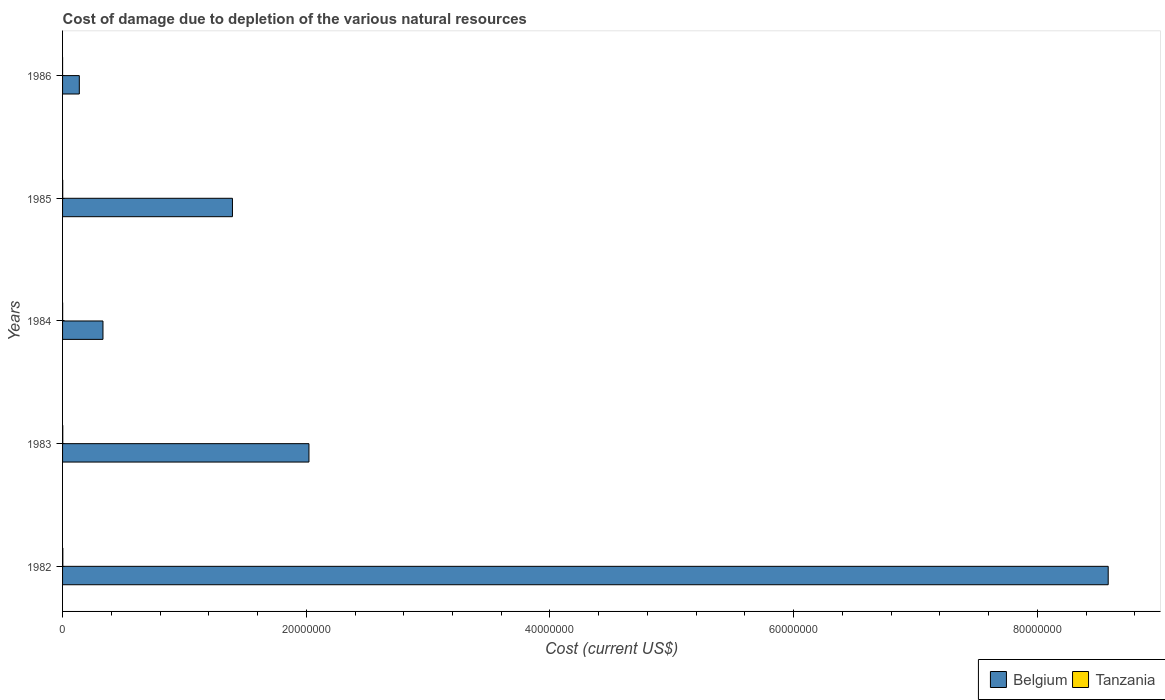How many bars are there on the 1st tick from the bottom?
Your response must be concise. 2. What is the label of the 5th group of bars from the top?
Ensure brevity in your answer.  1982. What is the cost of damage caused due to the depletion of various natural resources in Tanzania in 1986?
Ensure brevity in your answer.  129.44. Across all years, what is the maximum cost of damage caused due to the depletion of various natural resources in Tanzania?
Ensure brevity in your answer.  2.12e+04. Across all years, what is the minimum cost of damage caused due to the depletion of various natural resources in Tanzania?
Keep it short and to the point. 129.44. In which year was the cost of damage caused due to the depletion of various natural resources in Tanzania maximum?
Provide a short and direct response. 1982. What is the total cost of damage caused due to the depletion of various natural resources in Tanzania in the graph?
Your response must be concise. 5.66e+04. What is the difference between the cost of damage caused due to the depletion of various natural resources in Belgium in 1984 and that in 1985?
Offer a very short reply. -1.06e+07. What is the difference between the cost of damage caused due to the depletion of various natural resources in Tanzania in 1985 and the cost of damage caused due to the depletion of various natural resources in Belgium in 1984?
Offer a terse response. -3.30e+06. What is the average cost of damage caused due to the depletion of various natural resources in Belgium per year?
Provide a succinct answer. 2.49e+07. In the year 1984, what is the difference between the cost of damage caused due to the depletion of various natural resources in Tanzania and cost of damage caused due to the depletion of various natural resources in Belgium?
Provide a succinct answer. -3.31e+06. What is the ratio of the cost of damage caused due to the depletion of various natural resources in Belgium in 1983 to that in 1984?
Offer a terse response. 6.1. What is the difference between the highest and the second highest cost of damage caused due to the depletion of various natural resources in Tanzania?
Your answer should be compact. 4899.83. What is the difference between the highest and the lowest cost of damage caused due to the depletion of various natural resources in Belgium?
Keep it short and to the point. 8.44e+07. In how many years, is the cost of damage caused due to the depletion of various natural resources in Tanzania greater than the average cost of damage caused due to the depletion of various natural resources in Tanzania taken over all years?
Offer a very short reply. 3. Is the sum of the cost of damage caused due to the depletion of various natural resources in Tanzania in 1983 and 1985 greater than the maximum cost of damage caused due to the depletion of various natural resources in Belgium across all years?
Your answer should be compact. No. What does the 2nd bar from the bottom in 1985 represents?
Give a very brief answer. Tanzania. How many bars are there?
Offer a terse response. 10. How many years are there in the graph?
Provide a short and direct response. 5. What is the difference between two consecutive major ticks on the X-axis?
Offer a terse response. 2.00e+07. Does the graph contain any zero values?
Offer a very short reply. No. Does the graph contain grids?
Give a very brief answer. No. Where does the legend appear in the graph?
Your response must be concise. Bottom right. How many legend labels are there?
Offer a terse response. 2. How are the legend labels stacked?
Ensure brevity in your answer.  Horizontal. What is the title of the graph?
Your answer should be compact. Cost of damage due to depletion of the various natural resources. What is the label or title of the X-axis?
Your response must be concise. Cost (current US$). What is the Cost (current US$) of Belgium in 1982?
Provide a succinct answer. 8.58e+07. What is the Cost (current US$) in Tanzania in 1982?
Offer a very short reply. 2.12e+04. What is the Cost (current US$) in Belgium in 1983?
Keep it short and to the point. 2.02e+07. What is the Cost (current US$) in Tanzania in 1983?
Provide a succinct answer. 1.63e+04. What is the Cost (current US$) in Belgium in 1984?
Make the answer very short. 3.32e+06. What is the Cost (current US$) in Tanzania in 1984?
Your response must be concise. 6142.58. What is the Cost (current US$) in Belgium in 1985?
Give a very brief answer. 1.39e+07. What is the Cost (current US$) of Tanzania in 1985?
Provide a succinct answer. 1.28e+04. What is the Cost (current US$) in Belgium in 1986?
Provide a succinct answer. 1.37e+06. What is the Cost (current US$) in Tanzania in 1986?
Provide a succinct answer. 129.44. Across all years, what is the maximum Cost (current US$) in Belgium?
Your answer should be very brief. 8.58e+07. Across all years, what is the maximum Cost (current US$) in Tanzania?
Your answer should be very brief. 2.12e+04. Across all years, what is the minimum Cost (current US$) of Belgium?
Your answer should be compact. 1.37e+06. Across all years, what is the minimum Cost (current US$) of Tanzania?
Provide a short and direct response. 129.44. What is the total Cost (current US$) in Belgium in the graph?
Your response must be concise. 1.25e+08. What is the total Cost (current US$) in Tanzania in the graph?
Your answer should be compact. 5.66e+04. What is the difference between the Cost (current US$) in Belgium in 1982 and that in 1983?
Give a very brief answer. 6.56e+07. What is the difference between the Cost (current US$) of Tanzania in 1982 and that in 1983?
Give a very brief answer. 4899.84. What is the difference between the Cost (current US$) in Belgium in 1982 and that in 1984?
Offer a very short reply. 8.25e+07. What is the difference between the Cost (current US$) of Tanzania in 1982 and that in 1984?
Give a very brief answer. 1.51e+04. What is the difference between the Cost (current US$) of Belgium in 1982 and that in 1985?
Make the answer very short. 7.19e+07. What is the difference between the Cost (current US$) in Tanzania in 1982 and that in 1985?
Your answer should be very brief. 8418.63. What is the difference between the Cost (current US$) of Belgium in 1982 and that in 1986?
Give a very brief answer. 8.44e+07. What is the difference between the Cost (current US$) in Tanzania in 1982 and that in 1986?
Ensure brevity in your answer.  2.11e+04. What is the difference between the Cost (current US$) in Belgium in 1983 and that in 1984?
Ensure brevity in your answer.  1.69e+07. What is the difference between the Cost (current US$) in Tanzania in 1983 and that in 1984?
Your answer should be compact. 1.02e+04. What is the difference between the Cost (current US$) of Belgium in 1983 and that in 1985?
Your response must be concise. 6.28e+06. What is the difference between the Cost (current US$) in Tanzania in 1983 and that in 1985?
Offer a terse response. 3518.8. What is the difference between the Cost (current US$) of Belgium in 1983 and that in 1986?
Your answer should be very brief. 1.88e+07. What is the difference between the Cost (current US$) in Tanzania in 1983 and that in 1986?
Your response must be concise. 1.62e+04. What is the difference between the Cost (current US$) in Belgium in 1984 and that in 1985?
Provide a succinct answer. -1.06e+07. What is the difference between the Cost (current US$) of Tanzania in 1984 and that in 1985?
Your answer should be compact. -6650.71. What is the difference between the Cost (current US$) of Belgium in 1984 and that in 1986?
Provide a succinct answer. 1.94e+06. What is the difference between the Cost (current US$) of Tanzania in 1984 and that in 1986?
Offer a very short reply. 6013.14. What is the difference between the Cost (current US$) of Belgium in 1985 and that in 1986?
Your response must be concise. 1.26e+07. What is the difference between the Cost (current US$) of Tanzania in 1985 and that in 1986?
Provide a short and direct response. 1.27e+04. What is the difference between the Cost (current US$) in Belgium in 1982 and the Cost (current US$) in Tanzania in 1983?
Keep it short and to the point. 8.58e+07. What is the difference between the Cost (current US$) of Belgium in 1982 and the Cost (current US$) of Tanzania in 1984?
Make the answer very short. 8.58e+07. What is the difference between the Cost (current US$) of Belgium in 1982 and the Cost (current US$) of Tanzania in 1985?
Your answer should be very brief. 8.58e+07. What is the difference between the Cost (current US$) of Belgium in 1982 and the Cost (current US$) of Tanzania in 1986?
Your response must be concise. 8.58e+07. What is the difference between the Cost (current US$) of Belgium in 1983 and the Cost (current US$) of Tanzania in 1984?
Keep it short and to the point. 2.02e+07. What is the difference between the Cost (current US$) of Belgium in 1983 and the Cost (current US$) of Tanzania in 1985?
Your response must be concise. 2.02e+07. What is the difference between the Cost (current US$) of Belgium in 1983 and the Cost (current US$) of Tanzania in 1986?
Ensure brevity in your answer.  2.02e+07. What is the difference between the Cost (current US$) of Belgium in 1984 and the Cost (current US$) of Tanzania in 1985?
Make the answer very short. 3.30e+06. What is the difference between the Cost (current US$) of Belgium in 1984 and the Cost (current US$) of Tanzania in 1986?
Give a very brief answer. 3.32e+06. What is the difference between the Cost (current US$) in Belgium in 1985 and the Cost (current US$) in Tanzania in 1986?
Ensure brevity in your answer.  1.39e+07. What is the average Cost (current US$) of Belgium per year?
Offer a very short reply. 2.49e+07. What is the average Cost (current US$) of Tanzania per year?
Give a very brief answer. 1.13e+04. In the year 1982, what is the difference between the Cost (current US$) in Belgium and Cost (current US$) in Tanzania?
Provide a succinct answer. 8.58e+07. In the year 1983, what is the difference between the Cost (current US$) of Belgium and Cost (current US$) of Tanzania?
Your answer should be compact. 2.02e+07. In the year 1984, what is the difference between the Cost (current US$) of Belgium and Cost (current US$) of Tanzania?
Provide a short and direct response. 3.31e+06. In the year 1985, what is the difference between the Cost (current US$) of Belgium and Cost (current US$) of Tanzania?
Ensure brevity in your answer.  1.39e+07. In the year 1986, what is the difference between the Cost (current US$) of Belgium and Cost (current US$) of Tanzania?
Provide a short and direct response. 1.37e+06. What is the ratio of the Cost (current US$) of Belgium in 1982 to that in 1983?
Provide a short and direct response. 4.24. What is the ratio of the Cost (current US$) in Tanzania in 1982 to that in 1983?
Your answer should be compact. 1.3. What is the ratio of the Cost (current US$) of Belgium in 1982 to that in 1984?
Your response must be concise. 25.88. What is the ratio of the Cost (current US$) of Tanzania in 1982 to that in 1984?
Your answer should be very brief. 3.45. What is the ratio of the Cost (current US$) of Belgium in 1982 to that in 1985?
Offer a very short reply. 6.16. What is the ratio of the Cost (current US$) in Tanzania in 1982 to that in 1985?
Offer a terse response. 1.66. What is the ratio of the Cost (current US$) in Belgium in 1982 to that in 1986?
Provide a short and direct response. 62.43. What is the ratio of the Cost (current US$) of Tanzania in 1982 to that in 1986?
Make the answer very short. 163.88. What is the ratio of the Cost (current US$) in Belgium in 1983 to that in 1984?
Offer a very short reply. 6.1. What is the ratio of the Cost (current US$) in Tanzania in 1983 to that in 1984?
Offer a terse response. 2.66. What is the ratio of the Cost (current US$) of Belgium in 1983 to that in 1985?
Provide a succinct answer. 1.45. What is the ratio of the Cost (current US$) in Tanzania in 1983 to that in 1985?
Offer a terse response. 1.28. What is the ratio of the Cost (current US$) in Belgium in 1983 to that in 1986?
Your answer should be very brief. 14.71. What is the ratio of the Cost (current US$) in Tanzania in 1983 to that in 1986?
Provide a short and direct response. 126.02. What is the ratio of the Cost (current US$) in Belgium in 1984 to that in 1985?
Keep it short and to the point. 0.24. What is the ratio of the Cost (current US$) in Tanzania in 1984 to that in 1985?
Keep it short and to the point. 0.48. What is the ratio of the Cost (current US$) of Belgium in 1984 to that in 1986?
Your answer should be compact. 2.41. What is the ratio of the Cost (current US$) in Tanzania in 1984 to that in 1986?
Keep it short and to the point. 47.46. What is the ratio of the Cost (current US$) in Belgium in 1985 to that in 1986?
Give a very brief answer. 10.14. What is the ratio of the Cost (current US$) in Tanzania in 1985 to that in 1986?
Offer a terse response. 98.84. What is the difference between the highest and the second highest Cost (current US$) of Belgium?
Ensure brevity in your answer.  6.56e+07. What is the difference between the highest and the second highest Cost (current US$) of Tanzania?
Offer a very short reply. 4899.84. What is the difference between the highest and the lowest Cost (current US$) of Belgium?
Your answer should be compact. 8.44e+07. What is the difference between the highest and the lowest Cost (current US$) of Tanzania?
Give a very brief answer. 2.11e+04. 